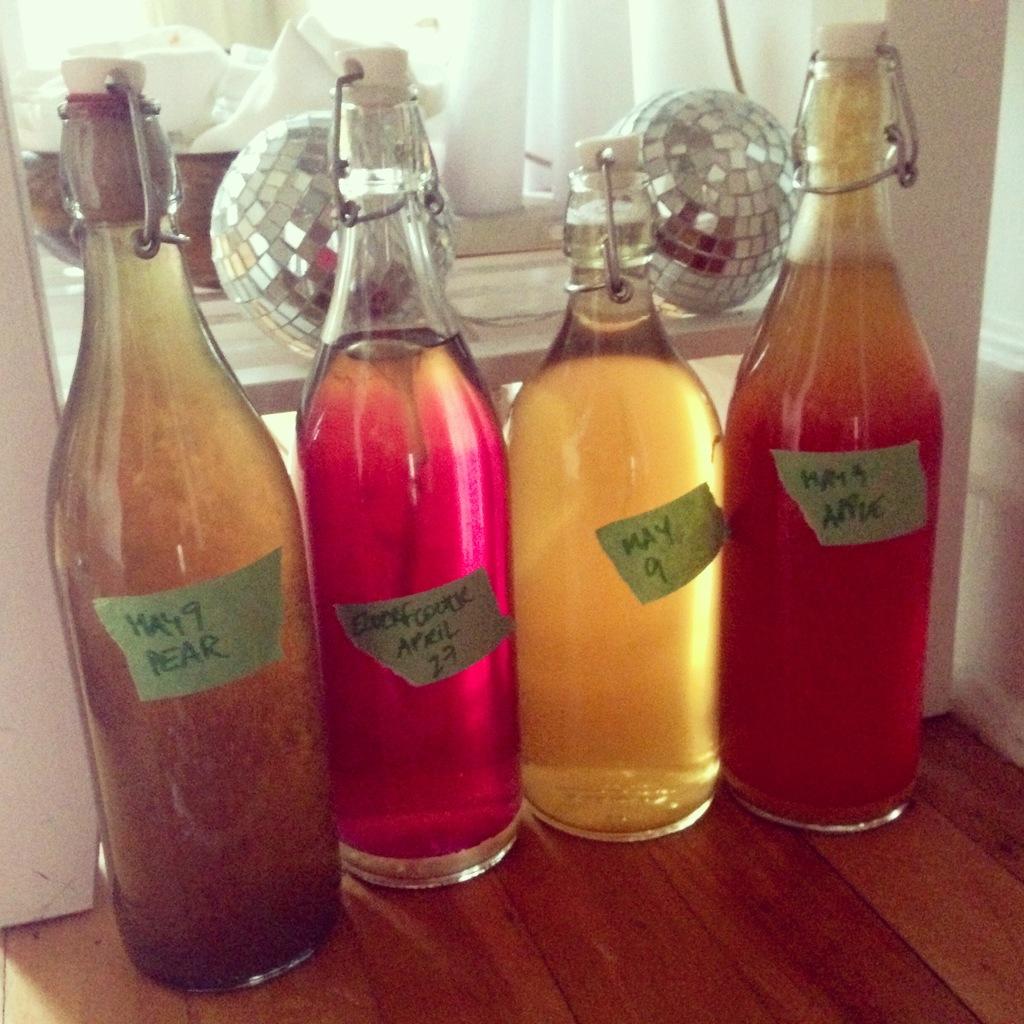What date does the pear drink have?
Give a very brief answer. May 9. What fruit is in the drink on the right?
Your answer should be very brief. Apple. 